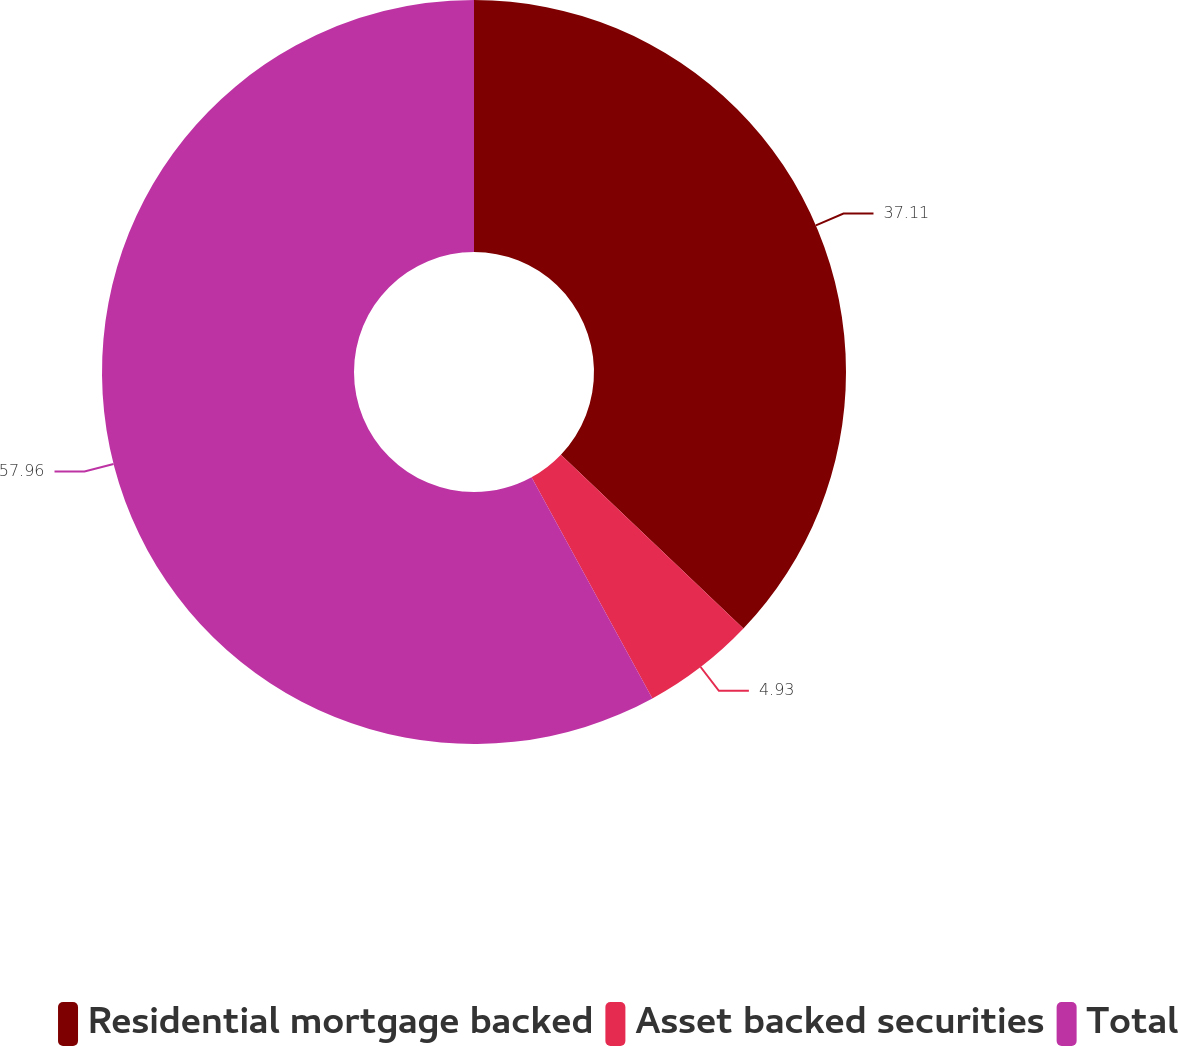Convert chart to OTSL. <chart><loc_0><loc_0><loc_500><loc_500><pie_chart><fcel>Residential mortgage backed<fcel>Asset backed securities<fcel>Total<nl><fcel>37.11%<fcel>4.93%<fcel>57.96%<nl></chart> 